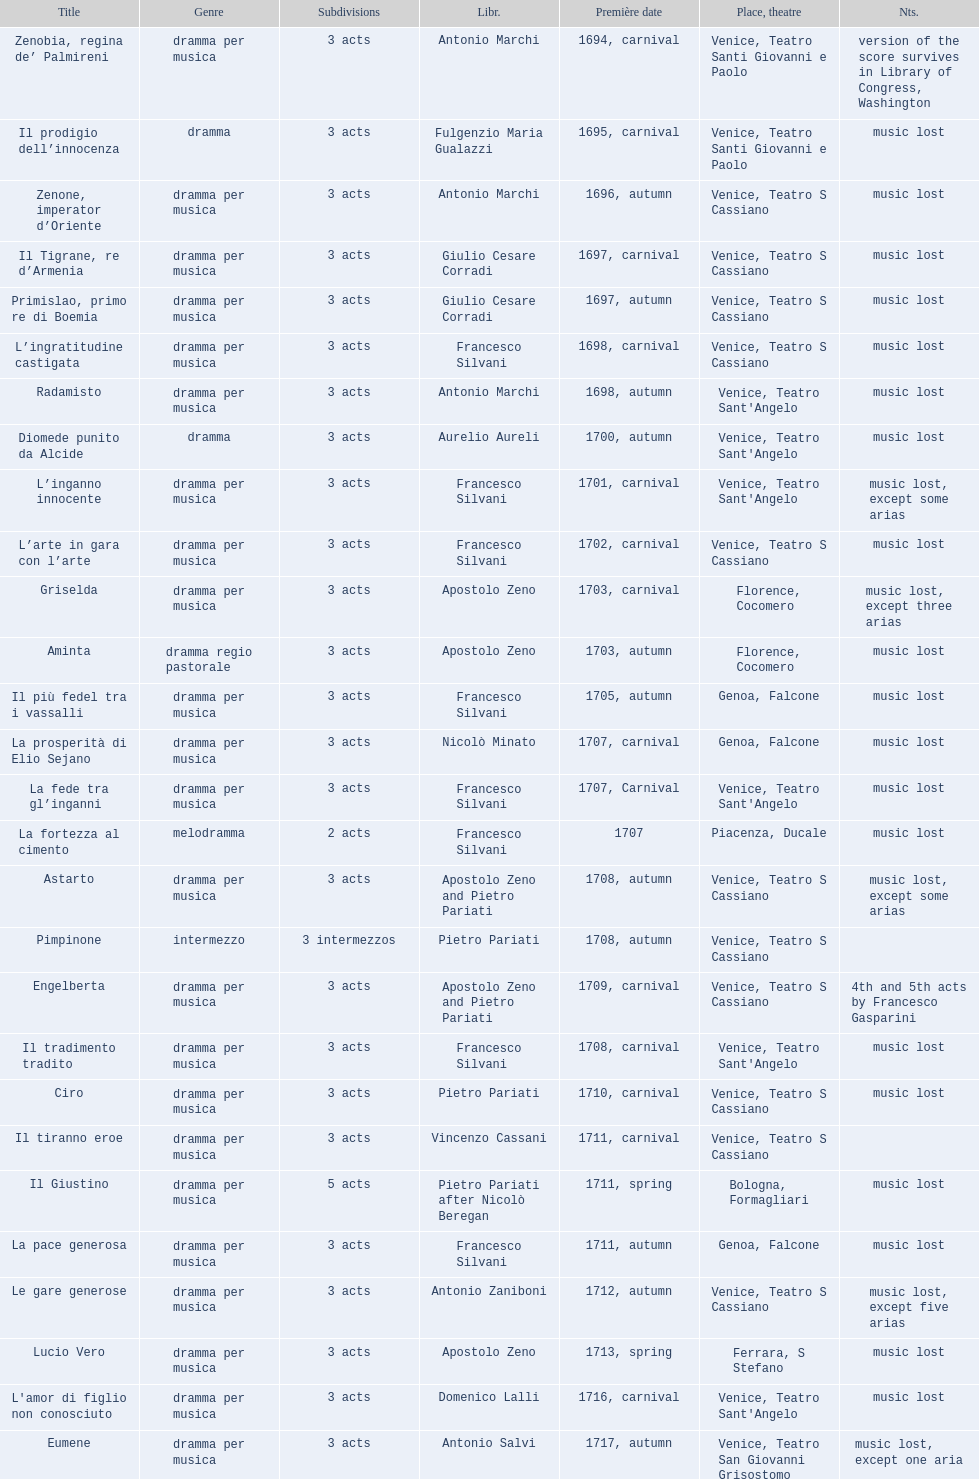Which opera has at least 5 acts? Il Giustino. 